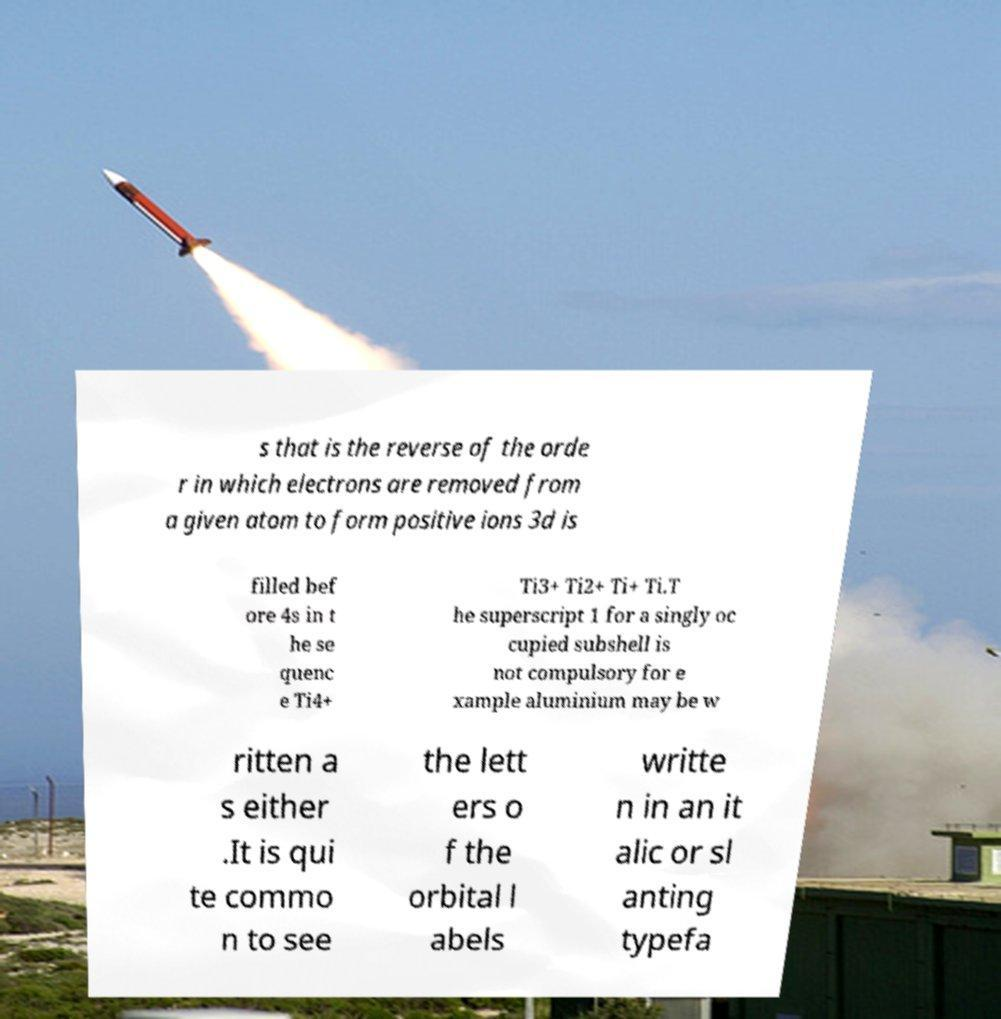Can you read and provide the text displayed in the image?This photo seems to have some interesting text. Can you extract and type it out for me? s that is the reverse of the orde r in which electrons are removed from a given atom to form positive ions 3d is filled bef ore 4s in t he se quenc e Ti4+ Ti3+ Ti2+ Ti+ Ti.T he superscript 1 for a singly oc cupied subshell is not compulsory for e xample aluminium may be w ritten a s either .It is qui te commo n to see the lett ers o f the orbital l abels writte n in an it alic or sl anting typefa 